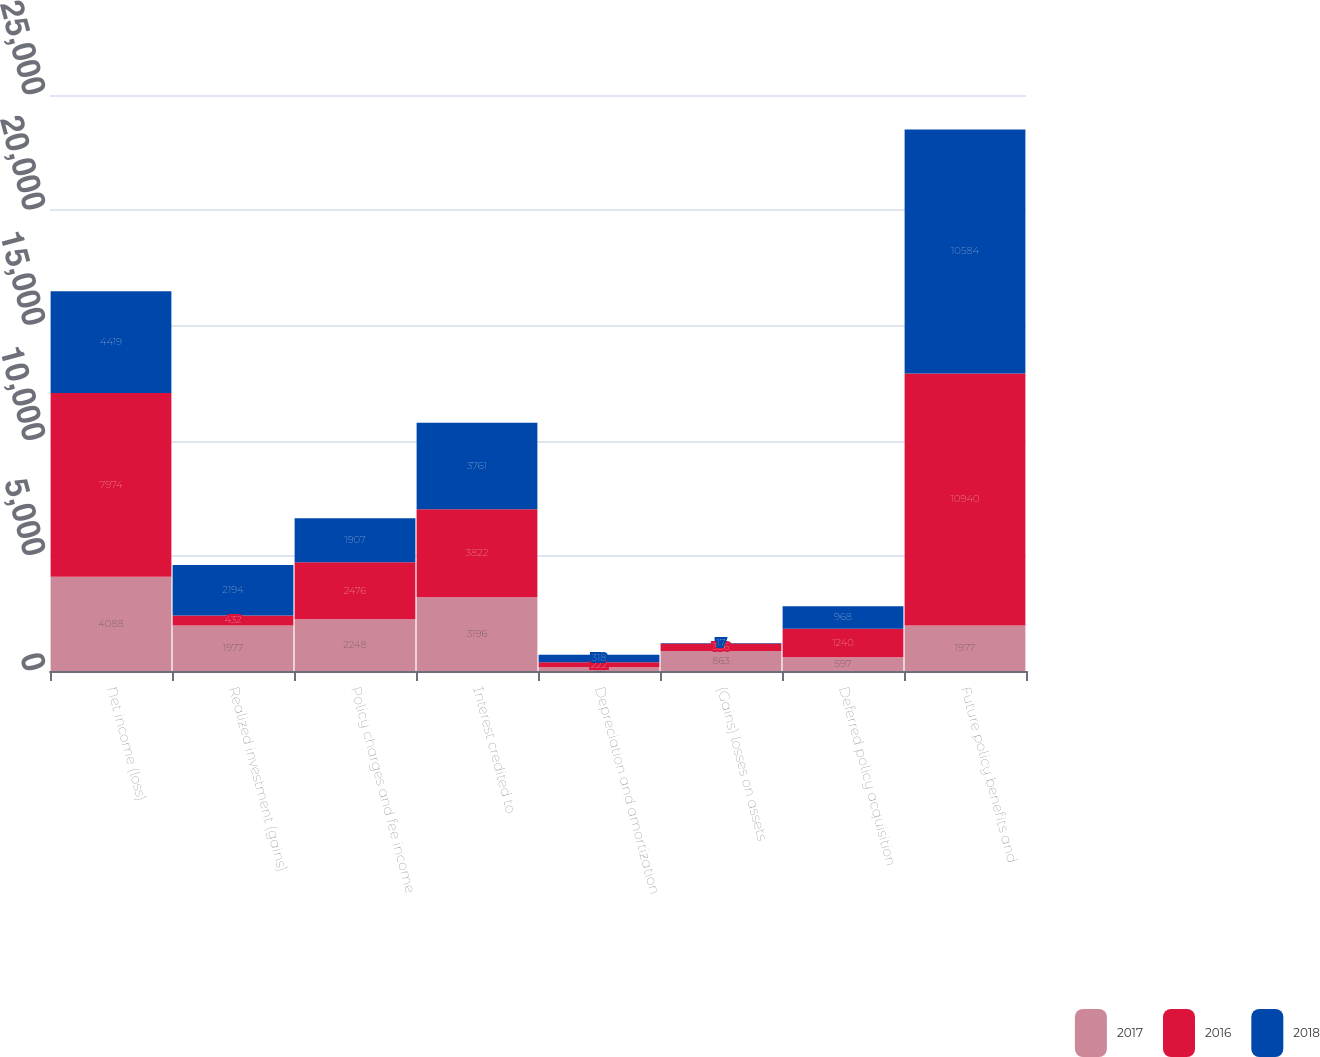<chart> <loc_0><loc_0><loc_500><loc_500><stacked_bar_chart><ecel><fcel>Net income (loss)<fcel>Realized investment (gains)<fcel>Policy charges and fee income<fcel>Interest credited to<fcel>Depreciation and amortization<fcel>(Gains) losses on assets<fcel>Deferred policy acquisition<fcel>Future policy benefits and<nl><fcel>2017<fcel>4088<fcel>1977<fcel>2248<fcel>3196<fcel>161<fcel>863<fcel>597<fcel>1977<nl><fcel>2016<fcel>7974<fcel>432<fcel>2476<fcel>3822<fcel>222<fcel>336<fcel>1240<fcel>10940<nl><fcel>2018<fcel>4419<fcel>2194<fcel>1907<fcel>3761<fcel>318<fcel>17<fcel>968<fcel>10584<nl></chart> 